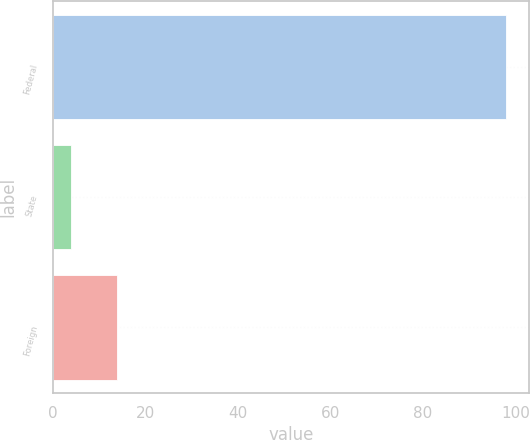Convert chart. <chart><loc_0><loc_0><loc_500><loc_500><bar_chart><fcel>Federal<fcel>State<fcel>Foreign<nl><fcel>98<fcel>4<fcel>14<nl></chart> 